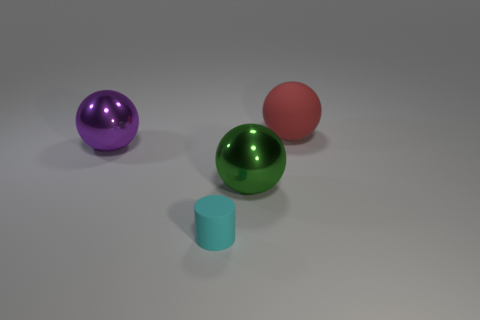Is there any other thing that is the same size as the cylinder?
Offer a very short reply. No. Is the small thing made of the same material as the thing to the right of the large green shiny thing?
Keep it short and to the point. Yes. What color is the tiny rubber cylinder?
Give a very brief answer. Cyan. The sphere that is in front of the shiny sphere behind the metal thing that is in front of the large purple shiny object is what color?
Offer a very short reply. Green. Does the large rubber object have the same shape as the rubber thing in front of the green thing?
Your answer should be very brief. No. There is a ball that is both left of the big red matte object and behind the large green sphere; what color is it?
Keep it short and to the point. Purple. Are there any other large objects that have the same shape as the green thing?
Offer a terse response. Yes. Are there any balls right of the big shiny object that is in front of the purple thing?
Your answer should be compact. Yes. How many objects are objects that are behind the cylinder or green things that are right of the matte cylinder?
Provide a short and direct response. 3. How many objects are matte things or balls behind the green sphere?
Keep it short and to the point. 3. 